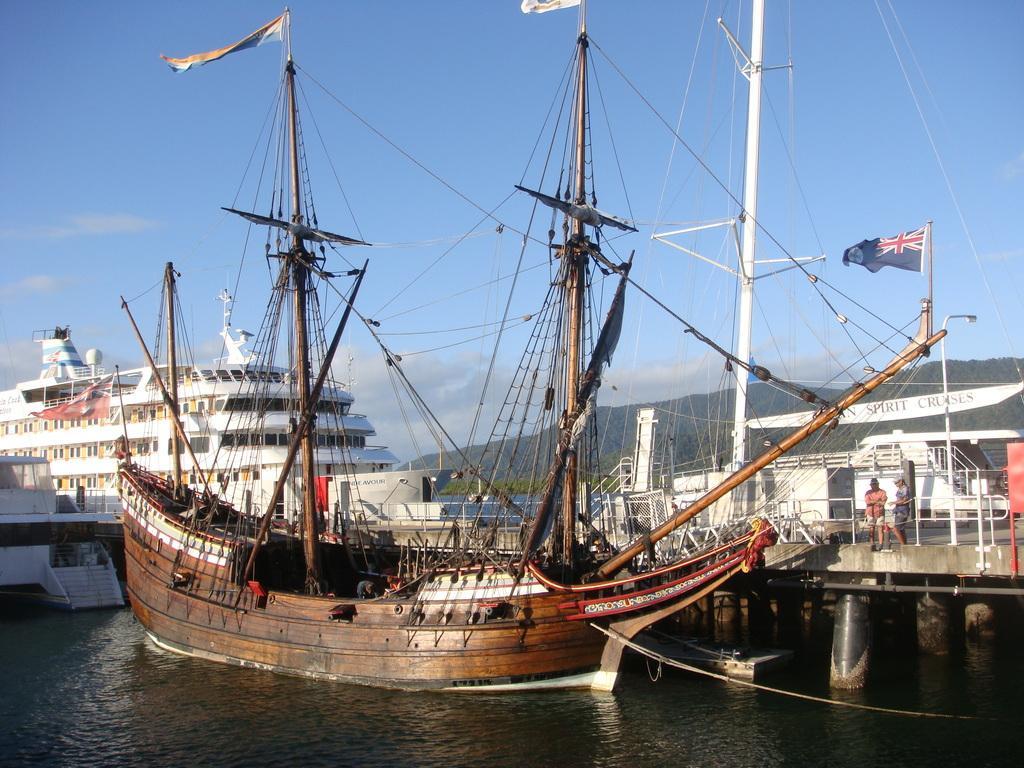Please provide a concise description of this image. In the picture we can see a boat in the water which is brown in color with some poles and wires to it and on the top of it we can see two flags and beside the boat we can see a walking bridge with railing and two people standing on it and behind the bridge we can see a boat which is white in color and behind the boats we can see a ship which is white in color with three floors and in the background we can see hills and near to it we can see some plants and behind the hills we can see the sky with clouds. 